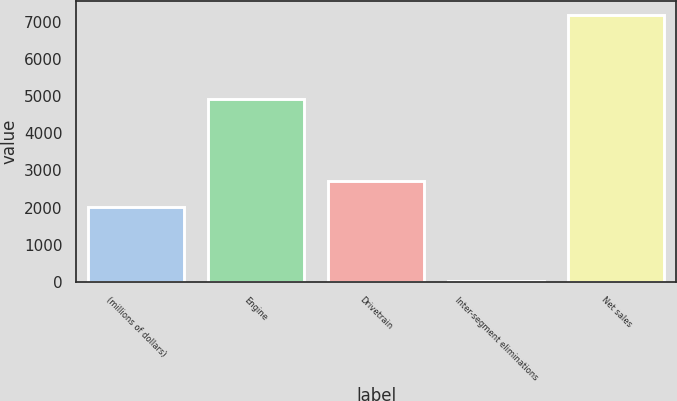Convert chart. <chart><loc_0><loc_0><loc_500><loc_500><bar_chart><fcel>(millions of dollars)<fcel>Engine<fcel>Drivetrain<fcel>Inter-segment eliminations<fcel>Net sales<nl><fcel>2012<fcel>4913<fcel>2727.47<fcel>28.5<fcel>7183.2<nl></chart> 